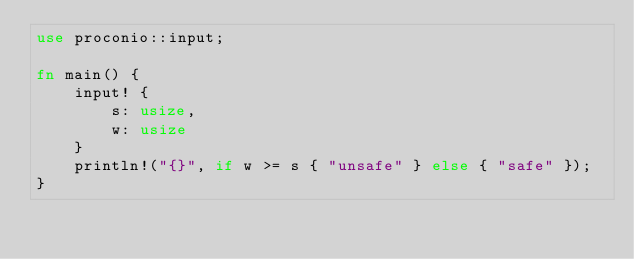Convert code to text. <code><loc_0><loc_0><loc_500><loc_500><_Rust_>use proconio::input;

fn main() {
    input! {
        s: usize,
        w: usize
    }
    println!("{}", if w >= s { "unsafe" } else { "safe" });
}
</code> 